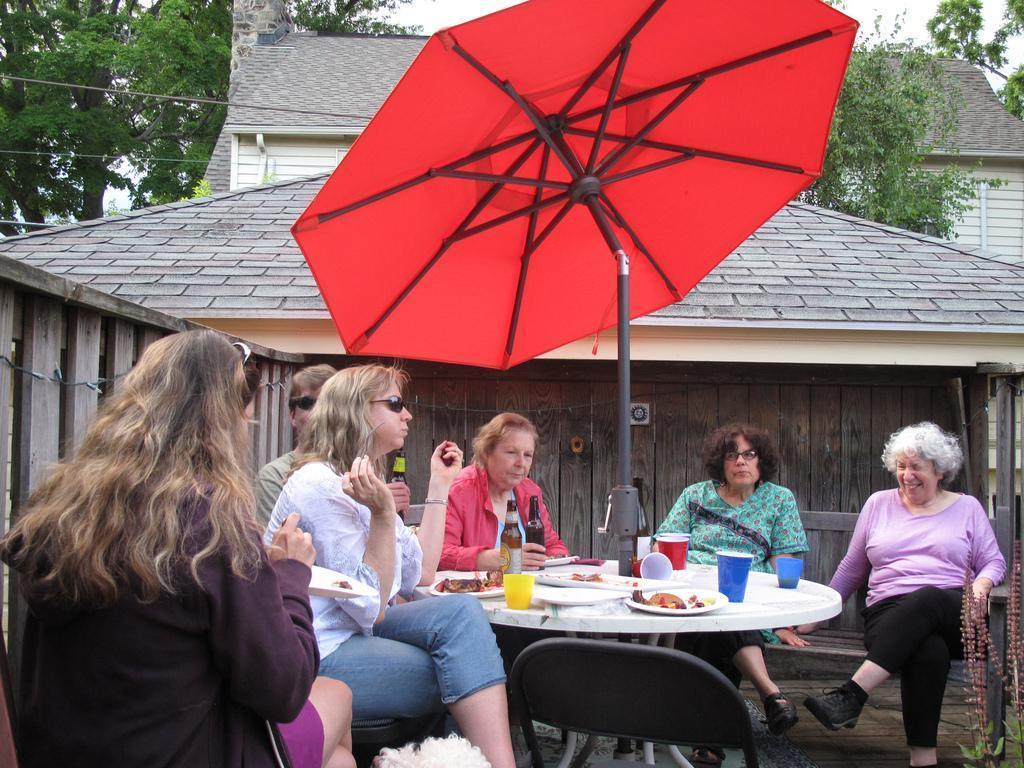How many yellow cups are in the image?
Give a very brief answer. 1. How many people have blonde hair?
Give a very brief answer. 4. 